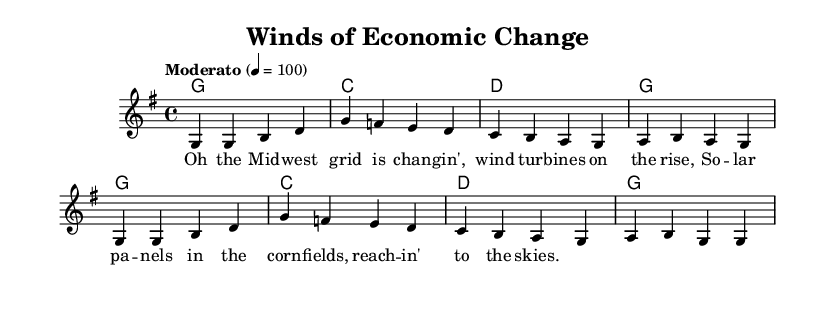What is the key signature of this music? The key signature indicated in the sheet music shows one sharp, which corresponds to G major.
Answer: G major What is the time signature of this music? The time signature is displayed at the beginning of the score. It shows 4/4, meaning there are four beats in each measure.
Answer: 4/4 What is the tempo marking of the piece? The tempo marking provided in the score indicates 'Moderato' with a metronome marking of 100 beats per minute, indicating a moderate speed.
Answer: Moderato 4 = 100 How many measures are in the melody section? The melody is written in two sections, and counting the measures gives a total of 8 measures.
Answer: 8 measures What chord is played in the first measure? The first measure has a G major chord, which is shown at the beginning of the harmonies section.
Answer: G What do the adapted lyrics talk about? The adapted lyrics refer to modern economic challenges related to renewable energy sources. They depict a transition in energy production in the Midwest.
Answer: Transition in energy production What structural element is typical for folk music observed in this tune? A repeated chorus or refrain structure is typical in folk music; the repeating melodic and lyrical patterns emphasize communal themes found in traditional folk.
Answer: Repeated chorus 